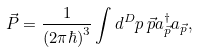Convert formula to latex. <formula><loc_0><loc_0><loc_500><loc_500>\vec { P } = \frac { 1 } { ( 2 \pi \hbar { ) } ^ { 3 } } \int d ^ { D } p \, \vec { p } a ^ { \dag } _ { \vec { p } } a _ { \vec { p } } ,</formula> 